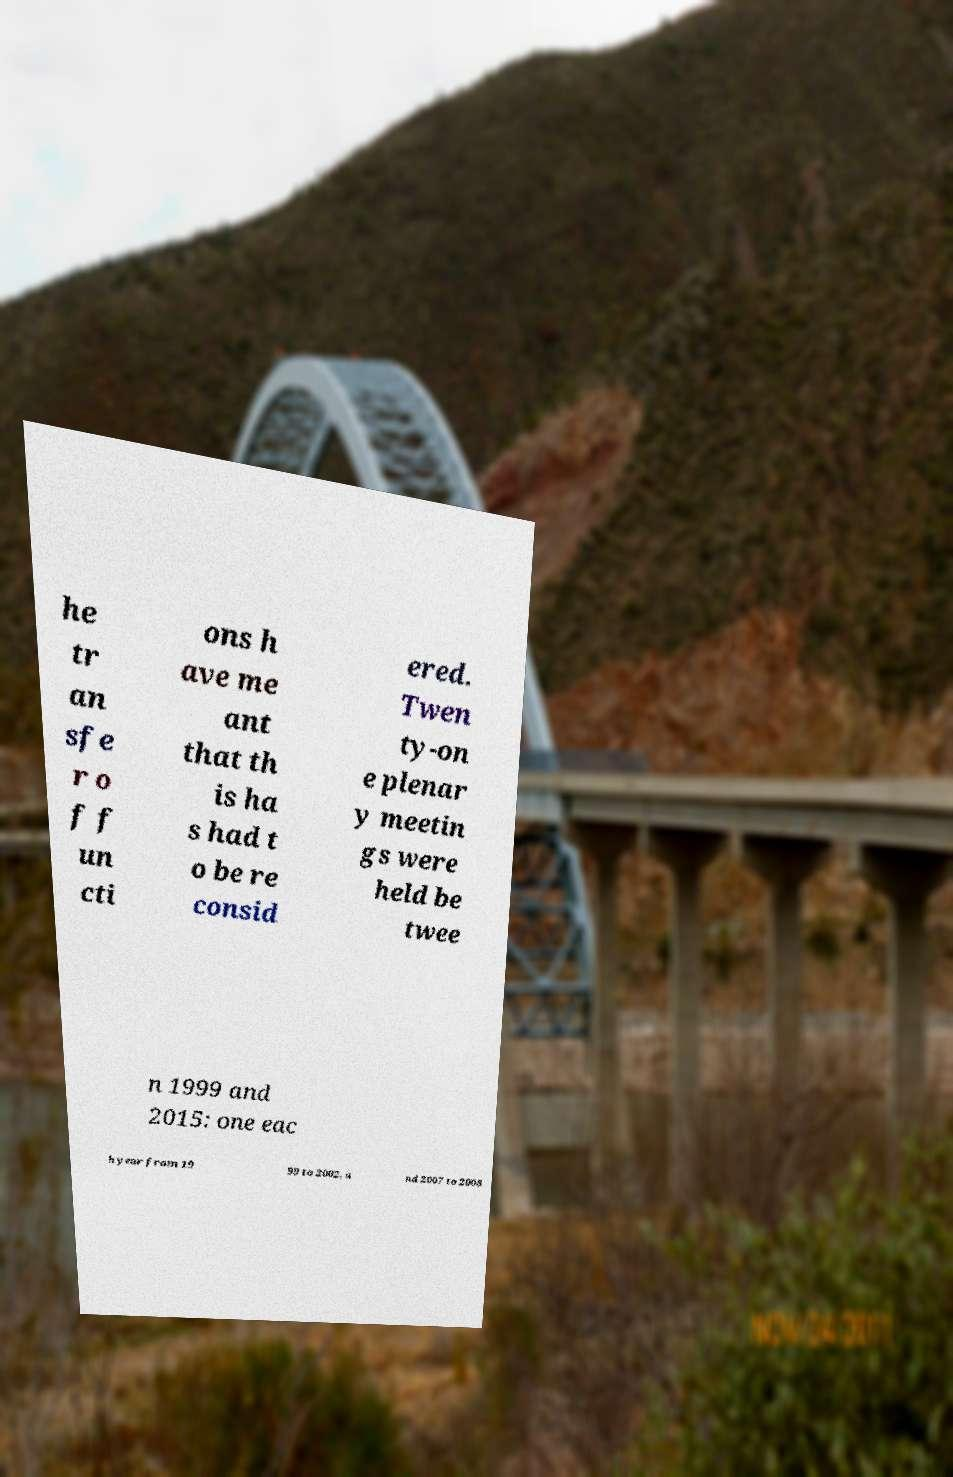Please read and relay the text visible in this image. What does it say? he tr an sfe r o f f un cti ons h ave me ant that th is ha s had t o be re consid ered. Twen ty-on e plenar y meetin gs were held be twee n 1999 and 2015: one eac h year from 19 99 to 2002, a nd 2007 to 2008 